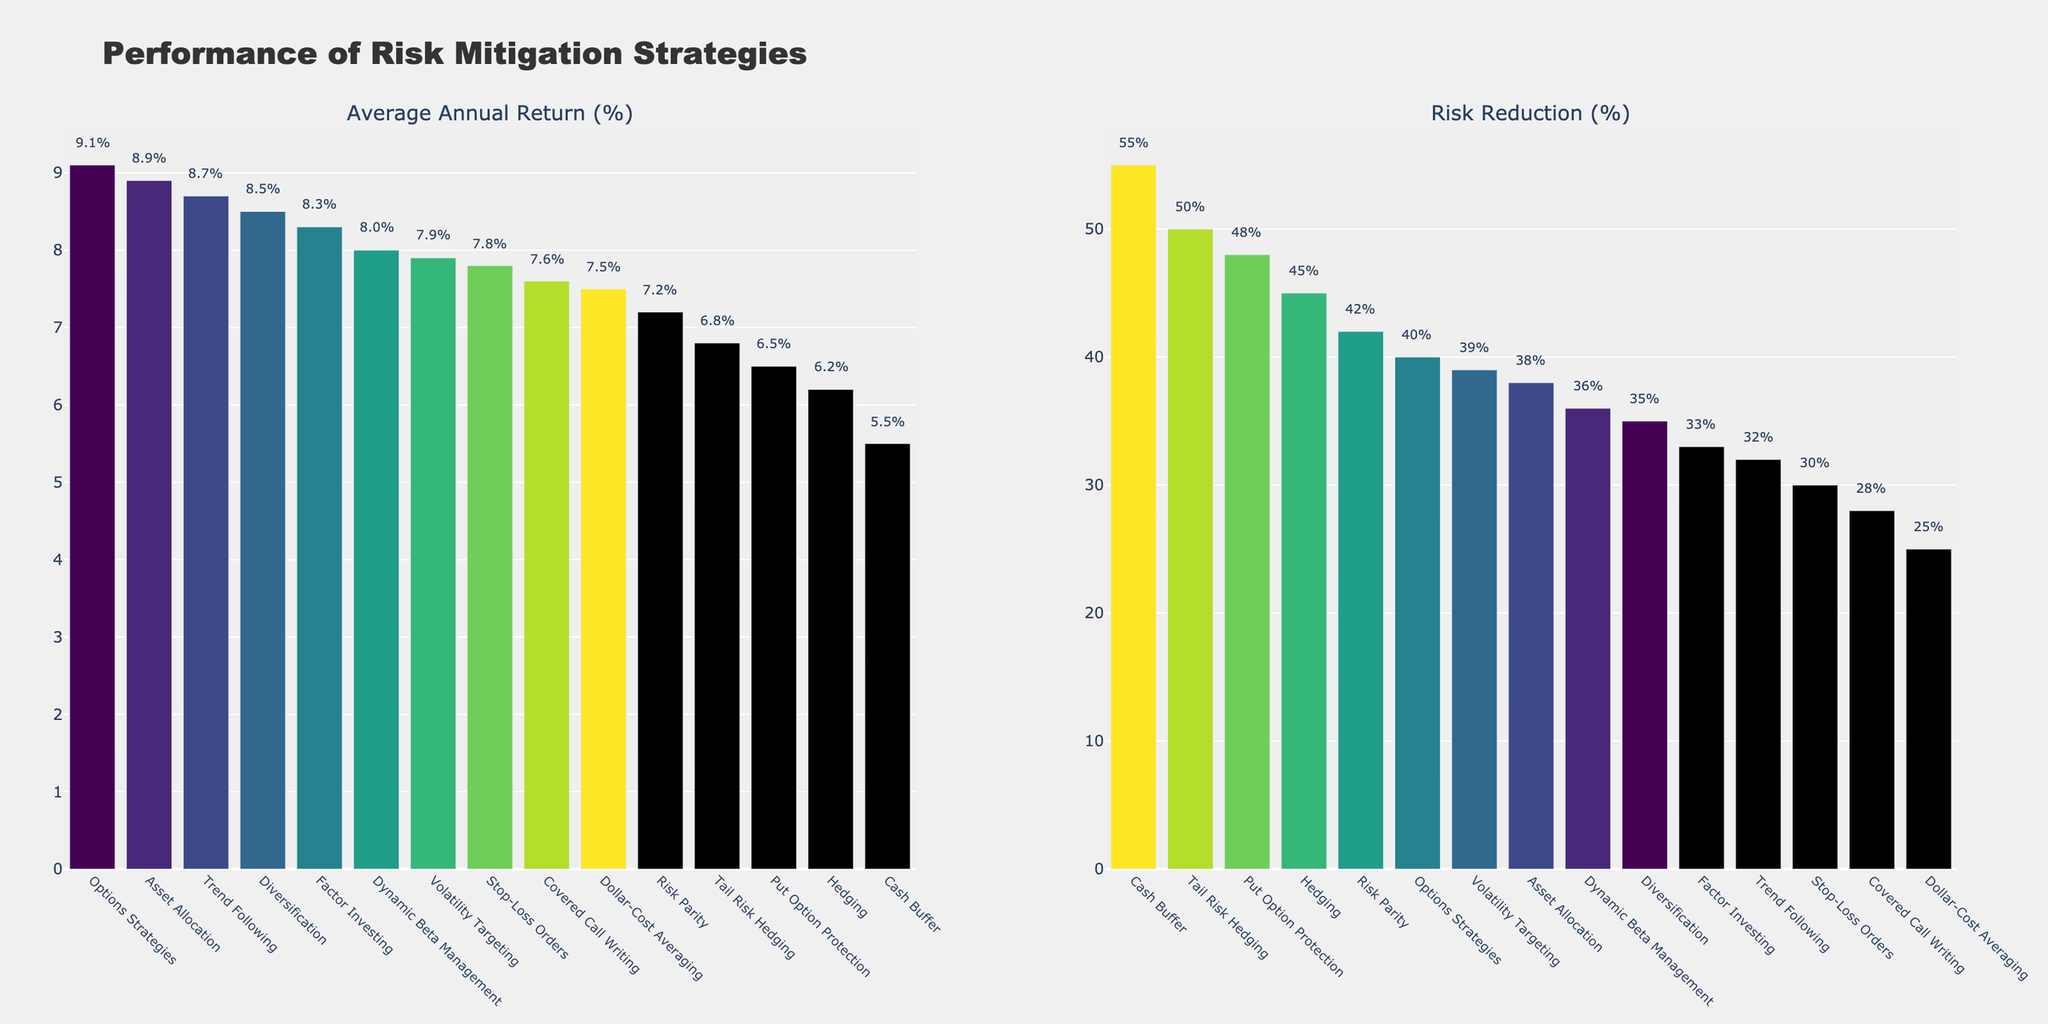Which strategy has the highest Average Annual Return (%)? By looking at the bar chart under the "Average Annual Return (%)" section and identifying the tallest bar, we can see that "Options Strategies" has the highest return.
Answer: Options Strategies Which strategy shows the highest Risk Reduction (%)? By examining the bar chart under the "Risk Reduction (%)" section and finding the tallest bar, we can see that "Cash Buffer" has the highest risk reduction.
Answer: Cash Buffer What is the difference in Average Annual Return (%) between the strategy with the highest return and the strategy with the lowest return? The highest return is 9.1% (Options Strategies), and the lowest return is 5.5% (Cash Buffer). The difference is 9.1% - 5.5% = 3.6%.
Answer: 3.6% How many strategies have a Risk Reduction (%) of 40% or higher? By counting the number of bars in the "Risk Reduction (%)" section that reach or exceed the 40% mark, we find that there are seven strategies: Hedging, Options Strategies, Risk Parity, Tail Risk Hedging, Put Option Protection, Dynamic Beta Management, and Cash Buffer.
Answer: 7 Which strategy has a higher Average Annual Return (%), "Trend Following" or "Dynamic Beta Management"? By comparing the heights of the bars for "Trend Following" (8.7%) and "Dynamic Beta Management" (8.0%) in the "Average Annual Return (%)" section, we see that "Trend Following" has the higher return.
Answer: Trend Following What is the average Risk Reduction (%) for the top three strategies in Risk Reduction (%)? The top three strategies are Cash Buffer (55%), Tail Risk Hedging (50%), and Put Option Protection (48%). The average is (55 + 50 + 48) / 3 = 51%.
Answer: 51% Which strategy has the second-lowest Average Annual Return (%) and what is its value? By identifying the second shortest bar in the "Average Annual Return (%)" section, we find "Put Option Protection" with a return of 6.5%.
Answer: Put Option Protection, 6.5% What is the median Risk Reduction (%) among all strategies? By listing the Risk Reduction (%) values in ascending order (25, 28, 30, 32, 33, 35, 36, 38, 39, 40, 42, 45, 48, 50, 55), the median is the 8th value, which is 38%.
Answer: 38% Which strategy has a higher Risk Reduction (%), "Diversification" or "Factor Investing"? By comparing the heights of the bars for "Diversification" (35%) and "Factor Investing" (33%) in the "Risk Reduction (%)" section, we see that "Diversification" has a higher risk reduction.
Answer: Diversification 